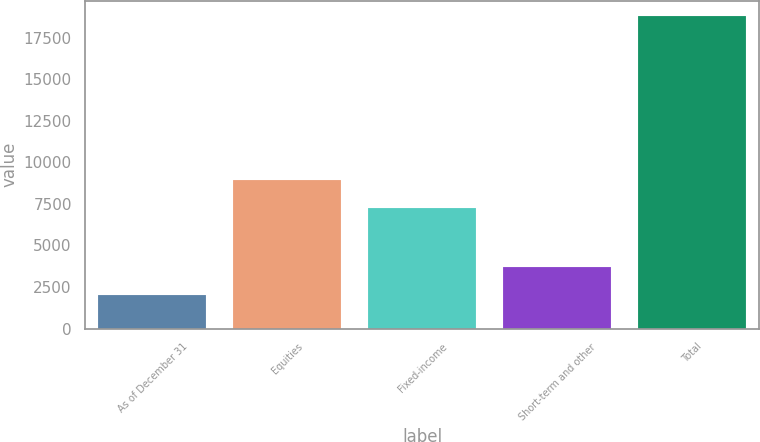<chart> <loc_0><loc_0><loc_500><loc_500><bar_chart><fcel>As of December 31<fcel>Equities<fcel>Fixed-income<fcel>Short-term and other<fcel>Total<nl><fcel>2009<fcel>8914.6<fcel>7236<fcel>3687.6<fcel>18795<nl></chart> 